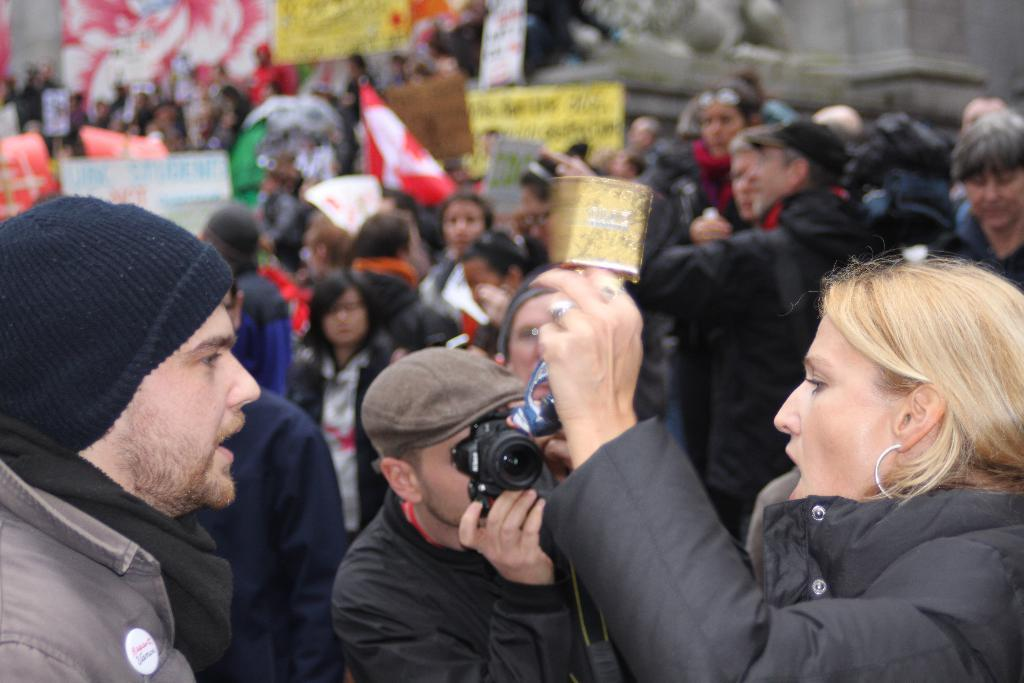How many people are present in the image? There are many people in the image. What are some people holding in the image? Some people are holding flags and banners in the image. What type of event is depicted in the image? The event depicted in the image appears to be a strike. Can you describe the actions of the man in the image? The man in the image is holding a camera. What is the woman in the image doing? The woman in the image is shouting. What type of teaching method is being used by the man with the bucket in the image? There is no man with a bucket present in the image. What color is the ray that is flying over the people in the image? There is no ray present in the image. 